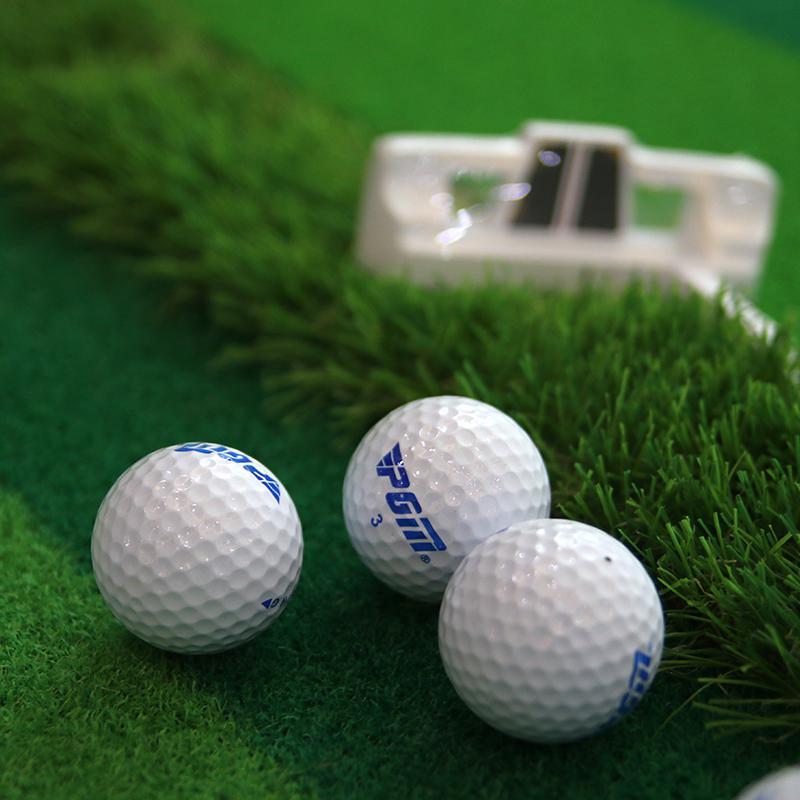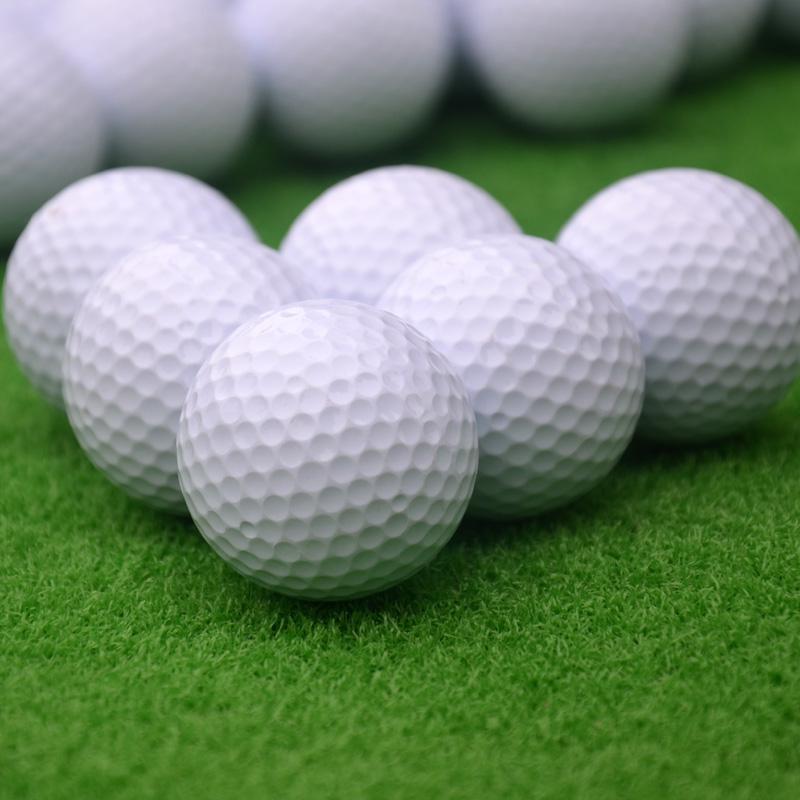The first image is the image on the left, the second image is the image on the right. Analyze the images presented: Is the assertion "Lettering is visible on some of the golf balls in one of the images." valid? Answer yes or no. Yes. The first image is the image on the left, the second image is the image on the right. For the images displayed, is the sentence "Both images show only white balls on green turf, with no logos or other markings on them." factually correct? Answer yes or no. No. 